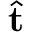Convert formula to latex. <formula><loc_0><loc_0><loc_500><loc_500>\hat { t }</formula> 